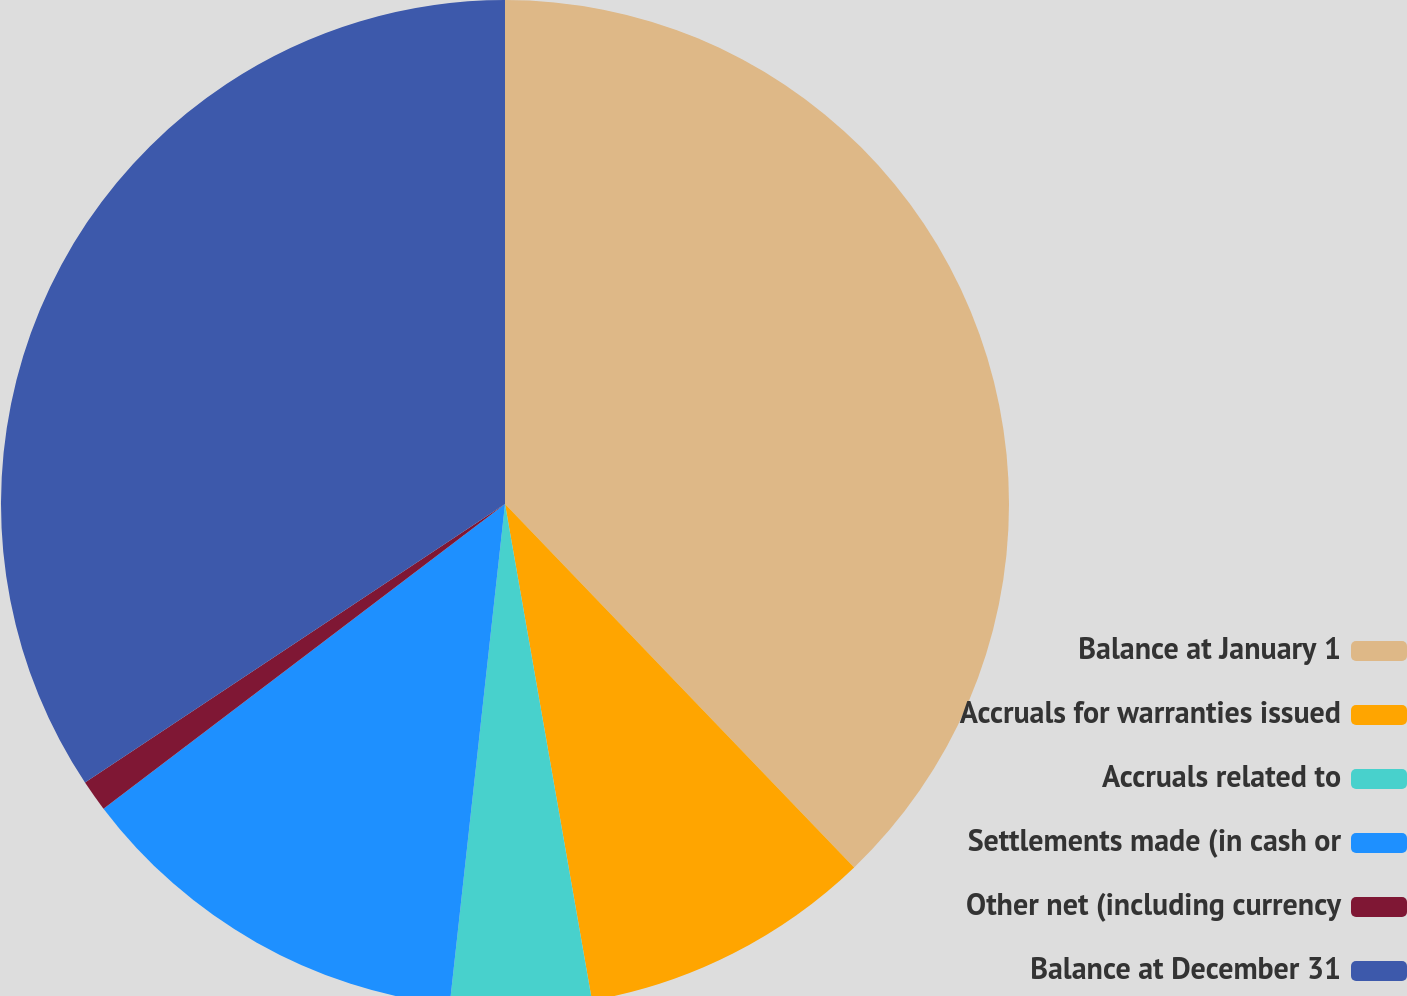Convert chart. <chart><loc_0><loc_0><loc_500><loc_500><pie_chart><fcel>Balance at January 1<fcel>Accruals for warranties issued<fcel>Accruals related to<fcel>Settlements made (in cash or<fcel>Other net (including currency<fcel>Balance at December 31<nl><fcel>37.82%<fcel>9.42%<fcel>4.51%<fcel>12.92%<fcel>1.01%<fcel>34.32%<nl></chart> 